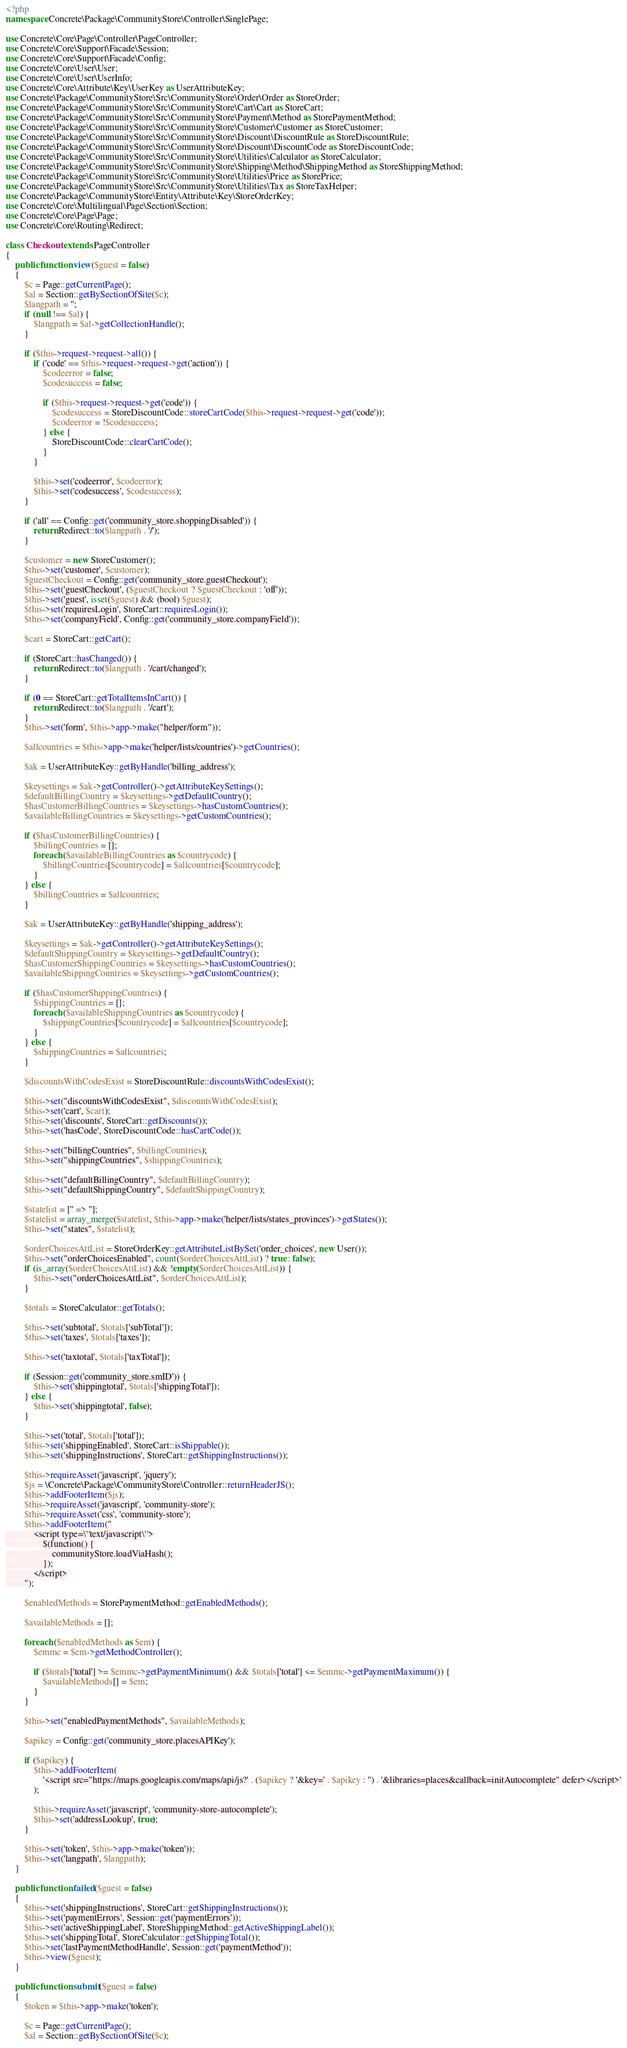<code> <loc_0><loc_0><loc_500><loc_500><_PHP_><?php
namespace Concrete\Package\CommunityStore\Controller\SinglePage;

use Concrete\Core\Page\Controller\PageController;
use Concrete\Core\Support\Facade\Session;
use Concrete\Core\Support\Facade\Config;
use Concrete\Core\User\User;
use Concrete\Core\User\UserInfo;
use Concrete\Core\Attribute\Key\UserKey as UserAttributeKey;
use Concrete\Package\CommunityStore\Src\CommunityStore\Order\Order as StoreOrder;
use Concrete\Package\CommunityStore\Src\CommunityStore\Cart\Cart as StoreCart;
use Concrete\Package\CommunityStore\Src\CommunityStore\Payment\Method as StorePaymentMethod;
use Concrete\Package\CommunityStore\Src\CommunityStore\Customer\Customer as StoreCustomer;
use Concrete\Package\CommunityStore\Src\CommunityStore\Discount\DiscountRule as StoreDiscountRule;
use Concrete\Package\CommunityStore\Src\CommunityStore\Discount\DiscountCode as StoreDiscountCode;
use Concrete\Package\CommunityStore\Src\CommunityStore\Utilities\Calculator as StoreCalculator;
use Concrete\Package\CommunityStore\Src\CommunityStore\Shipping\Method\ShippingMethod as StoreShippingMethod;
use Concrete\Package\CommunityStore\Src\CommunityStore\Utilities\Price as StorePrice;
use Concrete\Package\CommunityStore\Src\CommunityStore\Utilities\Tax as StoreTaxHelper;
use Concrete\Package\CommunityStore\Entity\Attribute\Key\StoreOrderKey;
use Concrete\Core\Multilingual\Page\Section\Section;
use Concrete\Core\Page\Page;
use Concrete\Core\Routing\Redirect;

class Checkout extends PageController
{
    public function view($guest = false)
    {
        $c = Page::getCurrentPage();
        $al = Section::getBySectionOfSite($c);
        $langpath = '';
        if (null !== $al) {
            $langpath = $al->getCollectionHandle();
        }

        if ($this->request->request->all()) {
            if ('code' == $this->request->request->get('action')) {
                $codeerror = false;
                $codesuccess = false;

                if ($this->request->request->get('code')) {
                    $codesuccess = StoreDiscountCode::storeCartCode($this->request->request->get('code'));
                    $codeerror = !$codesuccess;
                } else {
                    StoreDiscountCode::clearCartCode();
                }
            }

            $this->set('codeerror', $codeerror);
            $this->set('codesuccess', $codesuccess);
        }

        if ('all' == Config::get('community_store.shoppingDisabled')) {
            return Redirect::to($langpath . '/');
        }

        $customer = new StoreCustomer();
        $this->set('customer', $customer);
        $guestCheckout = Config::get('community_store.guestCheckout');
        $this->set('guestCheckout', ($guestCheckout ? $guestCheckout : 'off'));
        $this->set('guest', isset($guest) && (bool) $guest);
        $this->set('requiresLogin', StoreCart::requiresLogin());
        $this->set('companyField', Config::get('community_store.companyField'));

        $cart = StoreCart::getCart();

        if (StoreCart::hasChanged()) {
            return Redirect::to($langpath . '/cart/changed');
        }

        if (0 == StoreCart::getTotalItemsInCart()) {
            return Redirect::to($langpath . '/cart');
        }
        $this->set('form', $this->app->make("helper/form"));

        $allcountries = $this->app->make('helper/lists/countries')->getCountries();

        $ak = UserAttributeKey::getByHandle('billing_address');

        $keysettings = $ak->getController()->getAttributeKeySettings();
        $defaultBillingCountry = $keysettings->getDefaultCountry();
        $hasCustomerBillingCountries = $keysettings->hasCustomCountries();
        $availableBillingCountries = $keysettings->getCustomCountries();

        if ($hasCustomerBillingCountries) {
            $billingCountries = [];
            foreach ($availableBillingCountries as $countrycode) {
                $billingCountries[$countrycode] = $allcountries[$countrycode];
            }
        } else {
            $billingCountries = $allcountries;
        }

        $ak = UserAttributeKey::getByHandle('shipping_address');

        $keysettings = $ak->getController()->getAttributeKeySettings();
        $defaultShippingCountry = $keysettings->getDefaultCountry();
        $hasCustomerShippingCountries = $keysettings->hasCustomCountries();
        $availableShippingCountries = $keysettings->getCustomCountries();

        if ($hasCustomerShippingCountries) {
            $shippingCountries = [];
            foreach ($availableShippingCountries as $countrycode) {
                $shippingCountries[$countrycode] = $allcountries[$countrycode];
            }
        } else {
            $shippingCountries = $allcountries;
        }

        $discountsWithCodesExist = StoreDiscountRule::discountsWithCodesExist();

        $this->set("discountsWithCodesExist", $discountsWithCodesExist);
        $this->set('cart', $cart);
        $this->set('discounts', StoreCart::getDiscounts());
        $this->set('hasCode', StoreDiscountCode::hasCartCode());

        $this->set("billingCountries", $billingCountries);
        $this->set("shippingCountries", $shippingCountries);

        $this->set("defaultBillingCountry", $defaultBillingCountry);
        $this->set("defaultShippingCountry", $defaultShippingCountry);

        $statelist = ['' => ''];
        $statelist = array_merge($statelist, $this->app->make('helper/lists/states_provinces')->getStates());
        $this->set("states", $statelist);

        $orderChoicesAttList = StoreOrderKey::getAttributeListBySet('order_choices', new User());
        $this->set("orderChoicesEnabled", count($orderChoicesAttList) ? true : false);
        if (is_array($orderChoicesAttList) && !empty($orderChoicesAttList)) {
            $this->set("orderChoicesAttList", $orderChoicesAttList);
        }

        $totals = StoreCalculator::getTotals();

        $this->set('subtotal', $totals['subTotal']);
        $this->set('taxes', $totals['taxes']);

        $this->set('taxtotal', $totals['taxTotal']);

        if (Session::get('community_store.smID')) {
            $this->set('shippingtotal', $totals['shippingTotal']);
        } else {
            $this->set('shippingtotal', false);
        }

        $this->set('total', $totals['total']);
        $this->set('shippingEnabled', StoreCart::isShippable());
        $this->set('shippingInstructions', StoreCart::getShippingInstructions());

        $this->requireAsset('javascript', 'jquery');
        $js = \Concrete\Package\CommunityStore\Controller::returnHeaderJS();
        $this->addFooterItem($js);
        $this->requireAsset('javascript', 'community-store');
        $this->requireAsset('css', 'community-store');
        $this->addFooterItem("
            <script type=\"text/javascript\">
                $(function() {
                    communityStore.loadViaHash();
                });
            </script>
        ");

        $enabledMethods = StorePaymentMethod::getEnabledMethods();

        $availableMethods = [];

        foreach ($enabledMethods as $em) {
            $emmc = $em->getMethodController();

            if ($totals['total'] >= $emmc->getPaymentMinimum() && $totals['total'] <= $emmc->getPaymentMaximum()) {
                $availableMethods[] = $em;
            }
        }

        $this->set("enabledPaymentMethods", $availableMethods);

        $apikey = Config::get('community_store.placesAPIKey');

        if ($apikey) {
            $this->addFooterItem(
                '<script src="https://maps.googleapis.com/maps/api/js?' . ($apikey ? '&key=' . $apikey : '') . '&libraries=places&callback=initAutocomplete" defer></script>'
            );

            $this->requireAsset('javascript', 'community-store-autocomplete');
            $this->set('addressLookup', true);
        }

        $this->set('token', $this->app->make('token'));
        $this->set('langpath', $langpath);
    }

    public function failed($guest = false)
    {
        $this->set('shippingInstructions', StoreCart::getShippingInstructions());
        $this->set('paymentErrors', Session::get('paymentErrors'));
        $this->set('activeShippingLabel', StoreShippingMethod::getActiveShippingLabel());
        $this->set('shippingTotal', StoreCalculator::getShippingTotal());
        $this->set('lastPaymentMethodHandle', Session::get('paymentMethod'));
        $this->view($guest);
    }

    public function submit($guest = false)
    {
        $token = $this->app->make('token');

        $c = Page::getCurrentPage();
        $al = Section::getBySectionOfSite($c);</code> 